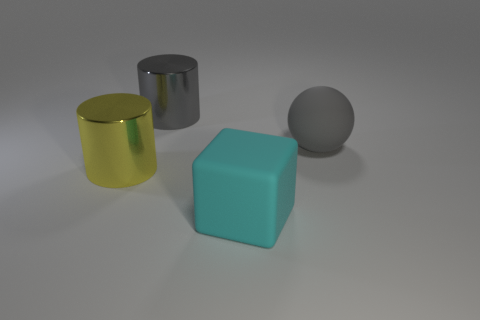Add 4 small shiny cylinders. How many objects exist? 8 Subtract all spheres. How many objects are left? 3 Add 2 spheres. How many spheres are left? 3 Add 3 cyan blocks. How many cyan blocks exist? 4 Subtract 0 brown spheres. How many objects are left? 4 Subtract all cyan blocks. Subtract all metal cylinders. How many objects are left? 1 